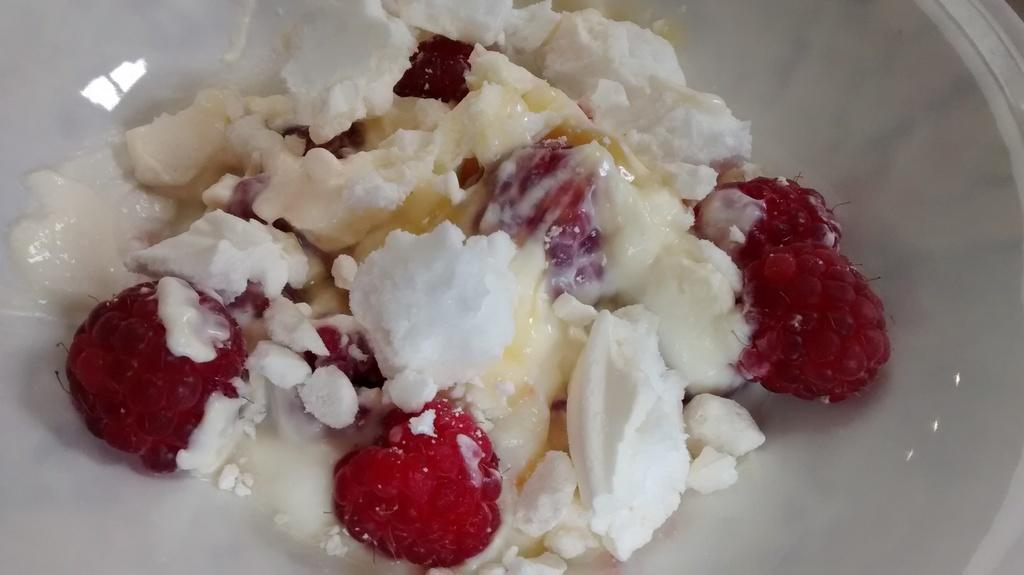What is the food item in the bowl in the image? There is a food item in a bowl in the image. What type of fruit can be seen in the image? There are raspberries in the image. What other ingredient is visible in the image? There is cream in the image. What type of toys can be seen in the image? There are no toys present in the image. How many apples are visible in the image? There are no apples present in the image. 